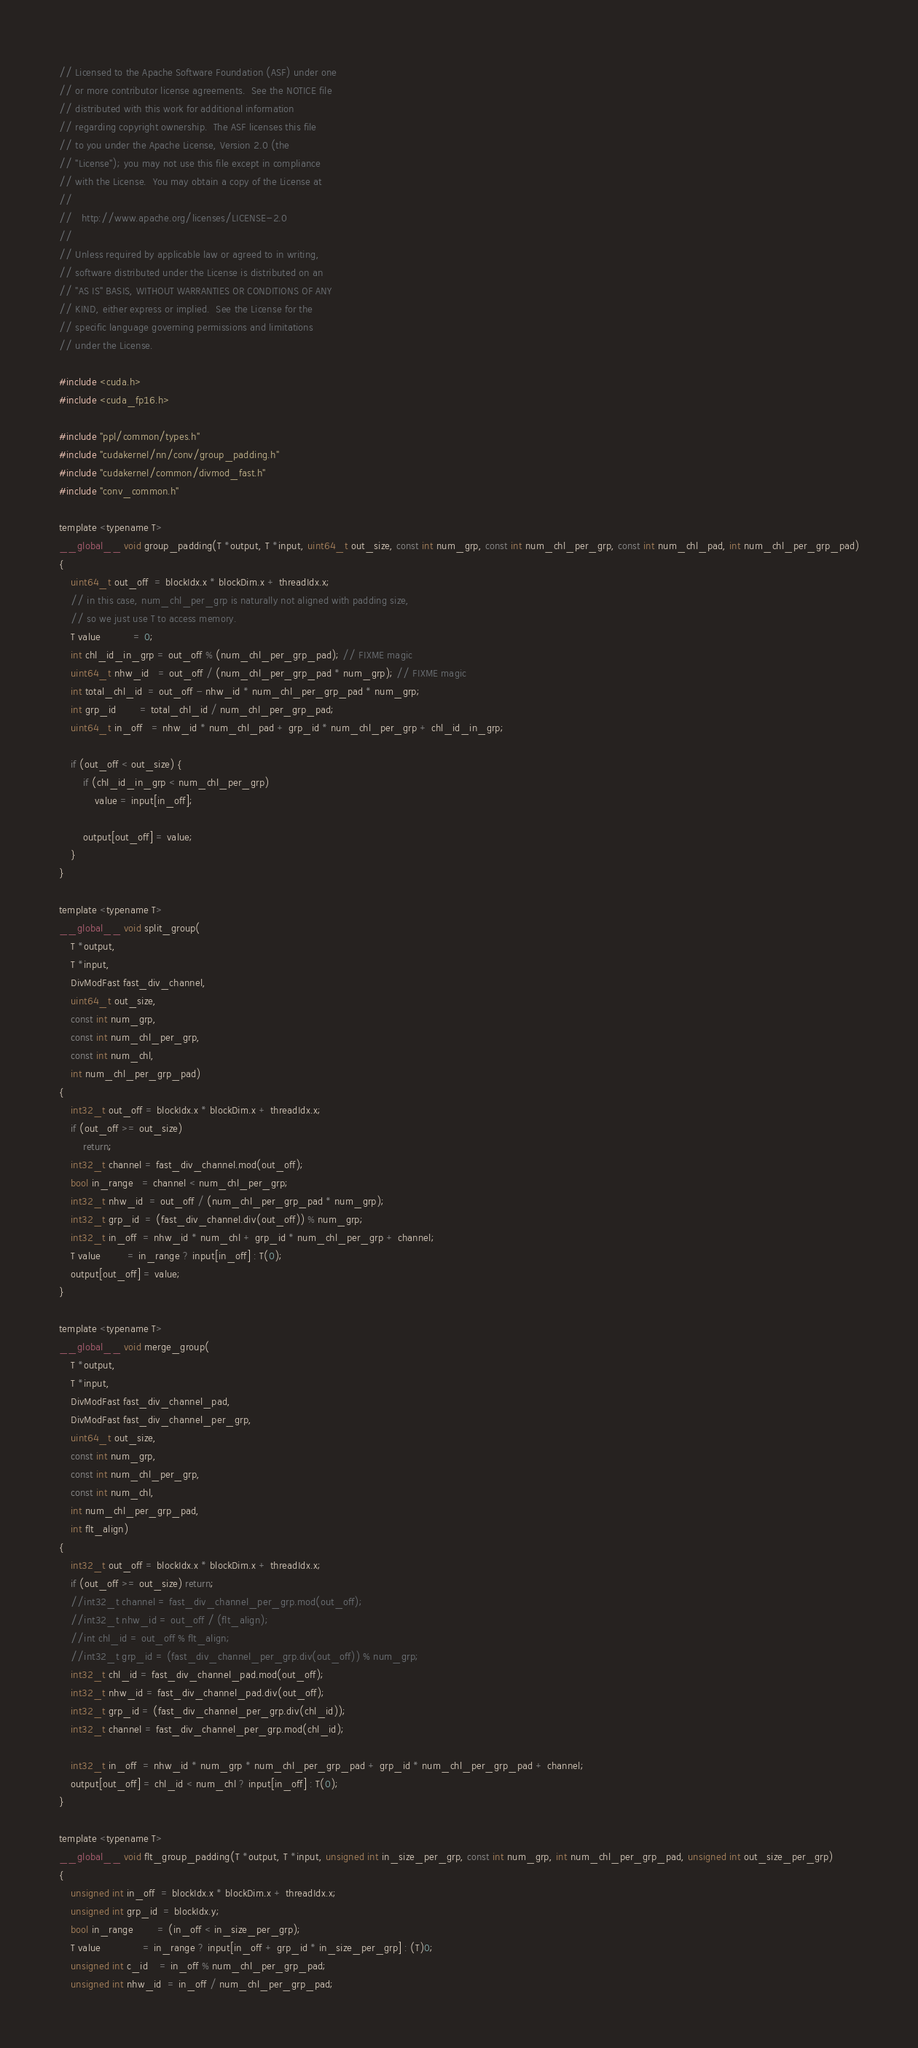<code> <loc_0><loc_0><loc_500><loc_500><_Cuda_>// Licensed to the Apache Software Foundation (ASF) under one
// or more contributor license agreements.  See the NOTICE file
// distributed with this work for additional information
// regarding copyright ownership.  The ASF licenses this file
// to you under the Apache License, Version 2.0 (the
// "License"); you may not use this file except in compliance
// with the License.  You may obtain a copy of the License at
//
//   http://www.apache.org/licenses/LICENSE-2.0
//
// Unless required by applicable law or agreed to in writing,
// software distributed under the License is distributed on an
// "AS IS" BASIS, WITHOUT WARRANTIES OR CONDITIONS OF ANY
// KIND, either express or implied.  See the License for the
// specific language governing permissions and limitations
// under the License.

#include <cuda.h>
#include <cuda_fp16.h>

#include "ppl/common/types.h"
#include "cudakernel/nn/conv/group_padding.h"
#include "cudakernel/common/divmod_fast.h"
#include "conv_common.h"

template <typename T>
__global__ void group_padding(T *output, T *input, uint64_t out_size, const int num_grp, const int num_chl_per_grp, const int num_chl_pad, int num_chl_per_grp_pad)
{
    uint64_t out_off  = blockIdx.x * blockDim.x + threadIdx.x;
    // in this case, num_chl_per_grp is naturally not aligned with padding size,
    // so we just use T to access memory.
    T value           = 0;
    int chl_id_in_grp = out_off % (num_chl_per_grp_pad); // FIXME magic
    uint64_t nhw_id   = out_off / (num_chl_per_grp_pad * num_grp); // FIXME magic
    int total_chl_id  = out_off - nhw_id * num_chl_per_grp_pad * num_grp;
    int grp_id        = total_chl_id / num_chl_per_grp_pad;
    uint64_t in_off   = nhw_id * num_chl_pad + grp_id * num_chl_per_grp + chl_id_in_grp;

    if (out_off < out_size) {
        if (chl_id_in_grp < num_chl_per_grp)
            value = input[in_off];

        output[out_off] = value;
    }
}

template <typename T>
__global__ void split_group(
    T *output,
    T *input,
    DivModFast fast_div_channel,
    uint64_t out_size,
    const int num_grp,
    const int num_chl_per_grp,
    const int num_chl,
    int num_chl_per_grp_pad)
{
    int32_t out_off = blockIdx.x * blockDim.x + threadIdx.x;
    if (out_off >= out_size)
        return;
    int32_t channel = fast_div_channel.mod(out_off);
    bool in_range   = channel < num_chl_per_grp;
    int32_t nhw_id  = out_off / (num_chl_per_grp_pad * num_grp);
    int32_t grp_id  = (fast_div_channel.div(out_off)) % num_grp;
    int32_t in_off  = nhw_id * num_chl + grp_id * num_chl_per_grp + channel;
    T value         = in_range ? input[in_off] : T(0);
    output[out_off] = value;
}

template <typename T>
__global__ void merge_group(
    T *output,
    T *input,
    DivModFast fast_div_channel_pad,
    DivModFast fast_div_channel_per_grp,
    uint64_t out_size,
    const int num_grp,
    const int num_chl_per_grp,
    const int num_chl,
    int num_chl_per_grp_pad,
    int flt_align)
{
    int32_t out_off = blockIdx.x * blockDim.x + threadIdx.x;
    if (out_off >= out_size) return;
    //int32_t channel = fast_div_channel_per_grp.mod(out_off);
    //int32_t nhw_id = out_off / (flt_align);
    //int chl_id = out_off % flt_align;
    //int32_t grp_id = (fast_div_channel_per_grp.div(out_off)) % num_grp;
    int32_t chl_id = fast_div_channel_pad.mod(out_off);
    int32_t nhw_id = fast_div_channel_pad.div(out_off);
    int32_t grp_id = (fast_div_channel_per_grp.div(chl_id));
    int32_t channel = fast_div_channel_per_grp.mod(chl_id);

    int32_t in_off  = nhw_id * num_grp * num_chl_per_grp_pad + grp_id * num_chl_per_grp_pad + channel;
    output[out_off] = chl_id < num_chl ? input[in_off] : T(0);
}

template <typename T>
__global__ void flt_group_padding(T *output, T *input, unsigned int in_size_per_grp, const int num_grp, int num_chl_per_grp_pad, unsigned int out_size_per_grp)
{
    unsigned int in_off  = blockIdx.x * blockDim.x + threadIdx.x;
    unsigned int grp_id  = blockIdx.y;
    bool in_range        = (in_off < in_size_per_grp);
    T value              = in_range ? input[in_off + grp_id * in_size_per_grp] : (T)0;
    unsigned int c_id    = in_off % num_chl_per_grp_pad;
    unsigned int nhw_id  = in_off / num_chl_per_grp_pad;</code> 